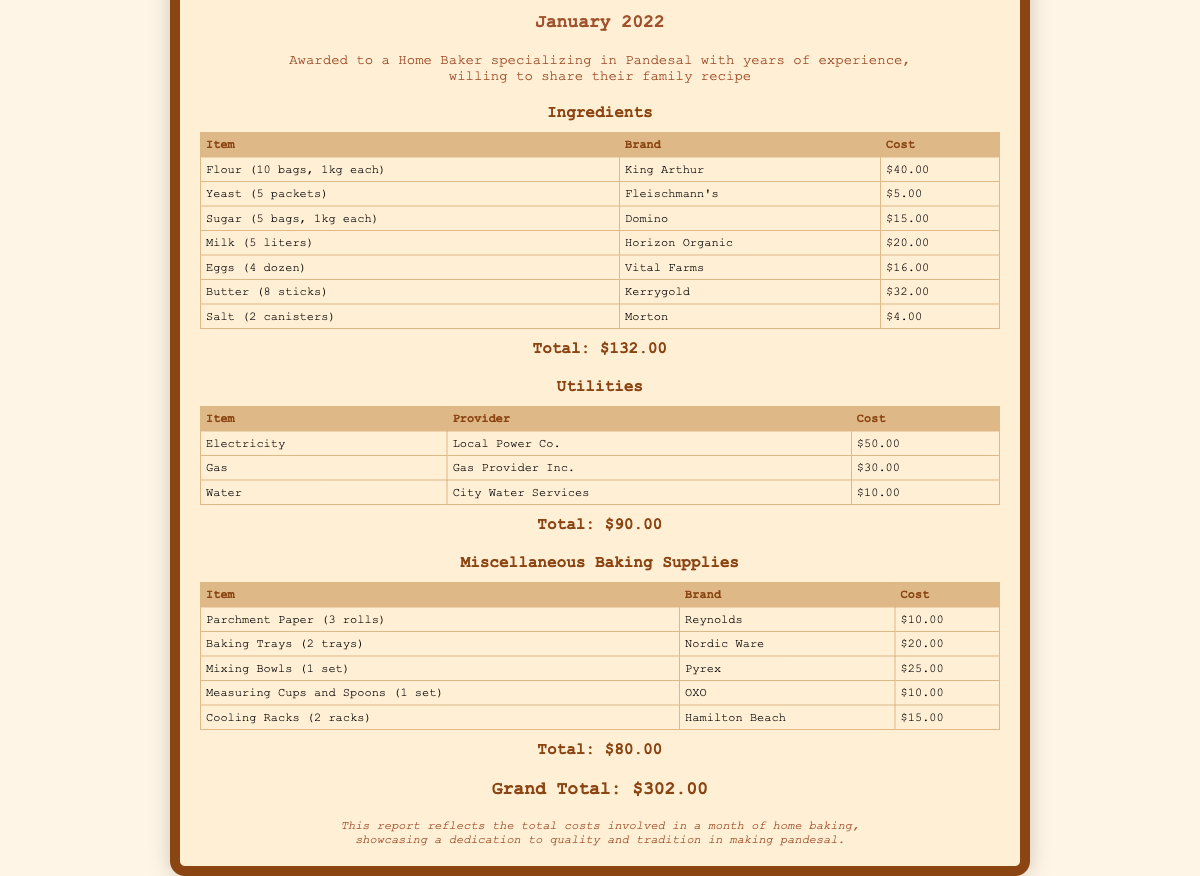What is the total cost of ingredients? The total cost of ingredients is shown in the document under the Ingredients section, which sums the costs of all listed items.
Answer: $132.00 How many packets of yeast were purchased? The document specifies that 5 packets of yeast were purchased in the Ingredients section.
Answer: 5 packets What brand of flour was bought? The document lists the brand of flour as King Arthur in the Ingredients section.
Answer: King Arthur What is the total cost for utilities? The total cost for utilities is found in the Utilities section, indicating the cumulative cost of all utilities listed.
Answer: $90.00 How many baking trays were acquired? The document states that 2 baking trays were purchased in the Miscellaneous Baking Supplies section.
Answer: 2 trays What is the grand total of all expenses? The grand total combines all costs from Ingredients, Utilities, and Miscellaneous Baking Supplies, as stated in the document.
Answer: $302.00 What brand are the measuring cups and spoons? The document notes that the measuring cups and spoons are from the brand OXO in the Miscellaneous Baking Supplies section.
Answer: OXO How many liters of milk were purchased? The document states that 5 liters of milk were purchased in the Ingredients section.
Answer: 5 liters What type of butter is listed in the Ingredients? The document specifies the type of butter as Kerrygold in the Ingredients section.
Answer: Kerrygold 